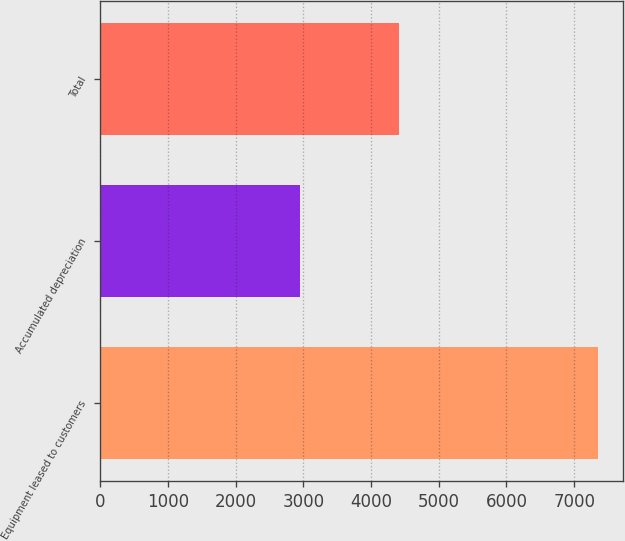Convert chart to OTSL. <chart><loc_0><loc_0><loc_500><loc_500><bar_chart><fcel>Equipment leased to customers<fcel>Accumulated depreciation<fcel>Total<nl><fcel>7356<fcel>2943<fcel>4413<nl></chart> 